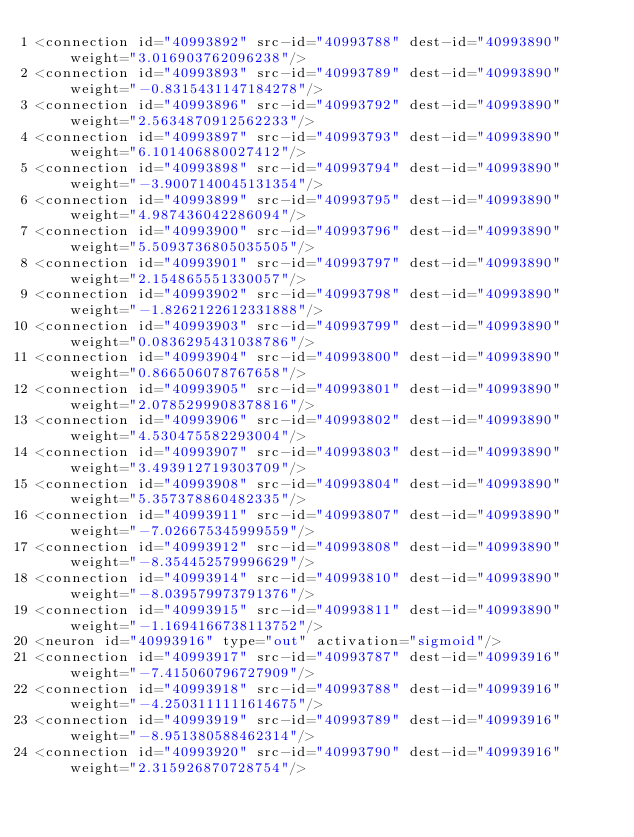Convert code to text. <code><loc_0><loc_0><loc_500><loc_500><_XML_><connection id="40993892" src-id="40993788" dest-id="40993890" weight="3.016903762096238"/>
<connection id="40993893" src-id="40993789" dest-id="40993890" weight="-0.8315431147184278"/>
<connection id="40993896" src-id="40993792" dest-id="40993890" weight="2.5634870912562233"/>
<connection id="40993897" src-id="40993793" dest-id="40993890" weight="6.101406880027412"/>
<connection id="40993898" src-id="40993794" dest-id="40993890" weight="-3.9007140045131354"/>
<connection id="40993899" src-id="40993795" dest-id="40993890" weight="4.987436042286094"/>
<connection id="40993900" src-id="40993796" dest-id="40993890" weight="5.5093736805035505"/>
<connection id="40993901" src-id="40993797" dest-id="40993890" weight="2.154865551330057"/>
<connection id="40993902" src-id="40993798" dest-id="40993890" weight="-1.8262122612331888"/>
<connection id="40993903" src-id="40993799" dest-id="40993890" weight="0.0836295431038786"/>
<connection id="40993904" src-id="40993800" dest-id="40993890" weight="0.866506078767658"/>
<connection id="40993905" src-id="40993801" dest-id="40993890" weight="2.0785299908378816"/>
<connection id="40993906" src-id="40993802" dest-id="40993890" weight="4.530475582293004"/>
<connection id="40993907" src-id="40993803" dest-id="40993890" weight="3.493912719303709"/>
<connection id="40993908" src-id="40993804" dest-id="40993890" weight="5.357378860482335"/>
<connection id="40993911" src-id="40993807" dest-id="40993890" weight="-7.026675345999559"/>
<connection id="40993912" src-id="40993808" dest-id="40993890" weight="-8.354452579996629"/>
<connection id="40993914" src-id="40993810" dest-id="40993890" weight="-8.039579973791376"/>
<connection id="40993915" src-id="40993811" dest-id="40993890" weight="-1.1694166738113752"/>
<neuron id="40993916" type="out" activation="sigmoid"/>
<connection id="40993917" src-id="40993787" dest-id="40993916" weight="-7.415060796727909"/>
<connection id="40993918" src-id="40993788" dest-id="40993916" weight="-4.2503111111614675"/>
<connection id="40993919" src-id="40993789" dest-id="40993916" weight="-8.951380588462314"/>
<connection id="40993920" src-id="40993790" dest-id="40993916" weight="2.315926870728754"/></code> 